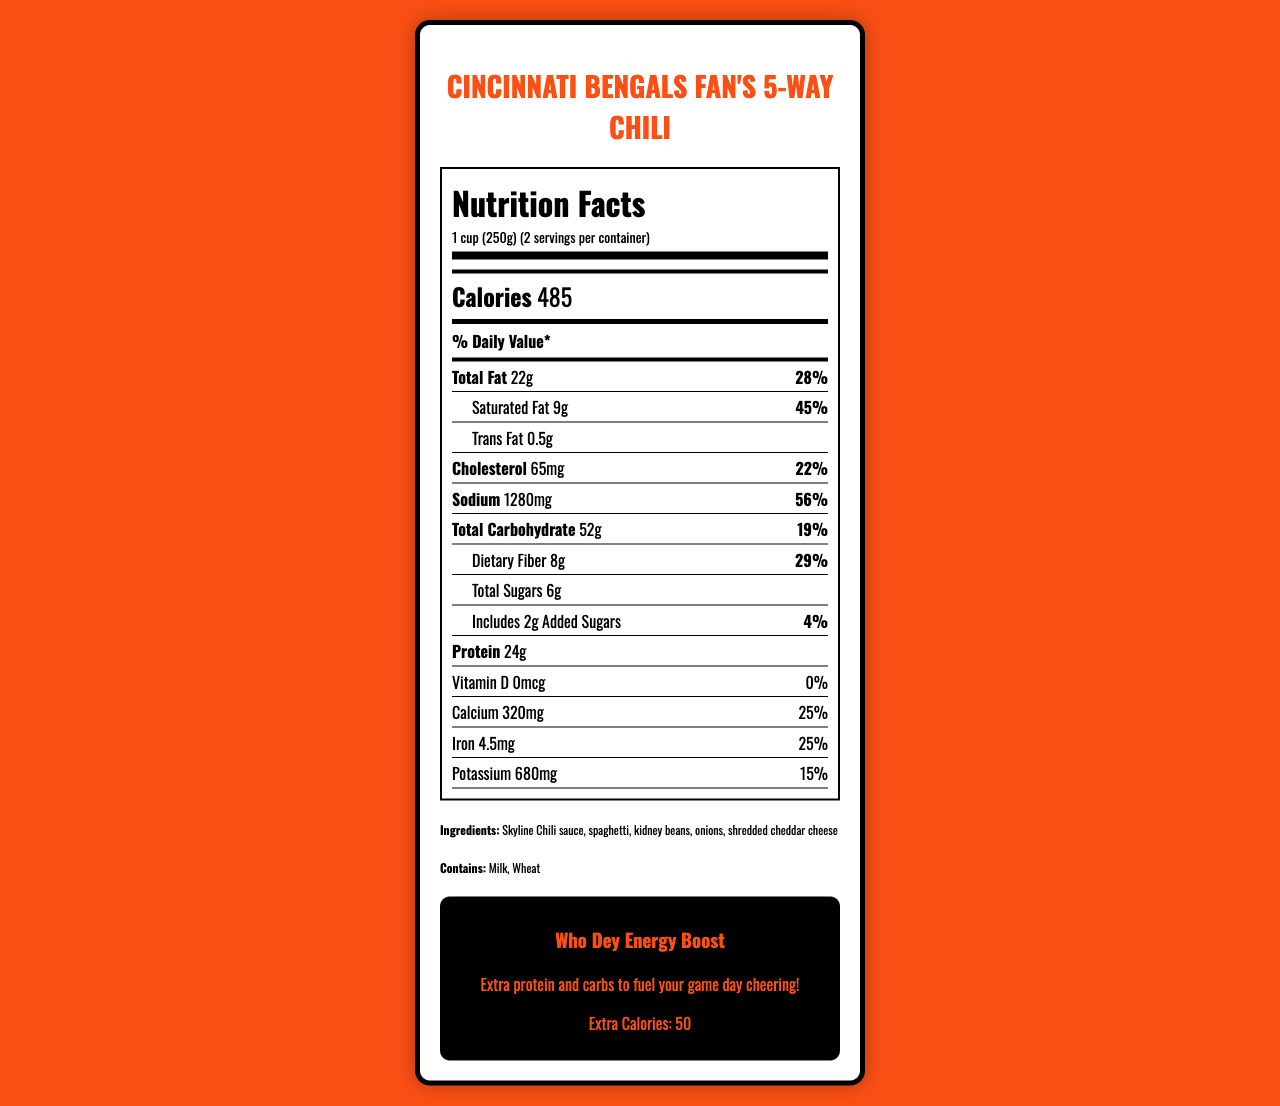what is the serving size of the Cincinnati-style chili 5-way? The serving size is listed at the beginning of the Nutrition Facts section as "1 cup (250g)".
Answer: 1 cup (250g) how many servings are in the container? The servings per container is mentioned in the document as "2 servings per container".
Answer: 2 servings how much protein is in one serving of the chili? The amount of protein per serving is specified as 24g in the Nutrition Facts.
Answer: 24g what are the ingredients in the Cincinnati-style chili 5-way? The ingredients are listed at the bottom of the document.
Answer: Skyline Chili sauce, spaghetti, kidney beans, onions, shredded cheddar cheese how much sodium is in one serving of the chili? The sodium content per serving is specified as 1280mg in the Nutrition Facts.
Answer: 1280mg how many grams of total fat are in one serving? A. 15g B. 20g C. 22g D. 25g The Nutrition Facts section specifies that one serving contains 22g of total fat.
Answer: C. 22g what is the daily value percentage of dietary fiber per serving? A. 19% B. 25% C. 28% D. 29% The document states that the daily value for dietary fiber per serving is 29%.
Answer: D. 29% does the chili contain any added sugars? The Nutrition Facts indicate that the chili includes 2g of added sugars.
Answer: Yes is there vitamin D in the chili? The document lists 0mcg of Vitamin D, which corresponds to 0% of the daily value.
Answer: No what allergens does the chili contain? The document states the allergens as "Milk" and "Wheat".
Answer: Milk, Wheat summarize the main idea of the Nutrition Facts Label for the Cincinnati-style chili 5-way. This summary captures the essential details about the nutritional content, ingredients, allergens, and the special "Who Dey Energy Boost" for fans.
Answer: The Cincinnati-style chili 5-way has a serving size of 1 cup (250g) and contains two servings per container. Each serving provides 485 calories, 22g of total fat, 9g of saturated fat, 0.5g of trans fat, 65mg of cholesterol, and 1280mg of sodium. It also contains 52g of total carbohydrates, 8g of dietary fiber, 6g of total sugars (including 2g of added sugars), and 24g of protein. Key ingredients include Skyline Chili sauce, spaghetti, kidney beans, onions, and shredded cheddar cheese, with milk and wheat as allergens. Additionally, there's a "Who Dey Energy Boost" section highlighting extra nutrients for game day cheering. how much extra protein does the "Who Dey Energy Boost" provide? The document does not specify an exact amount of extra protein provided by the "Who Dey Energy Boost". It only mentions extra calories.
Answer: Not enough information 